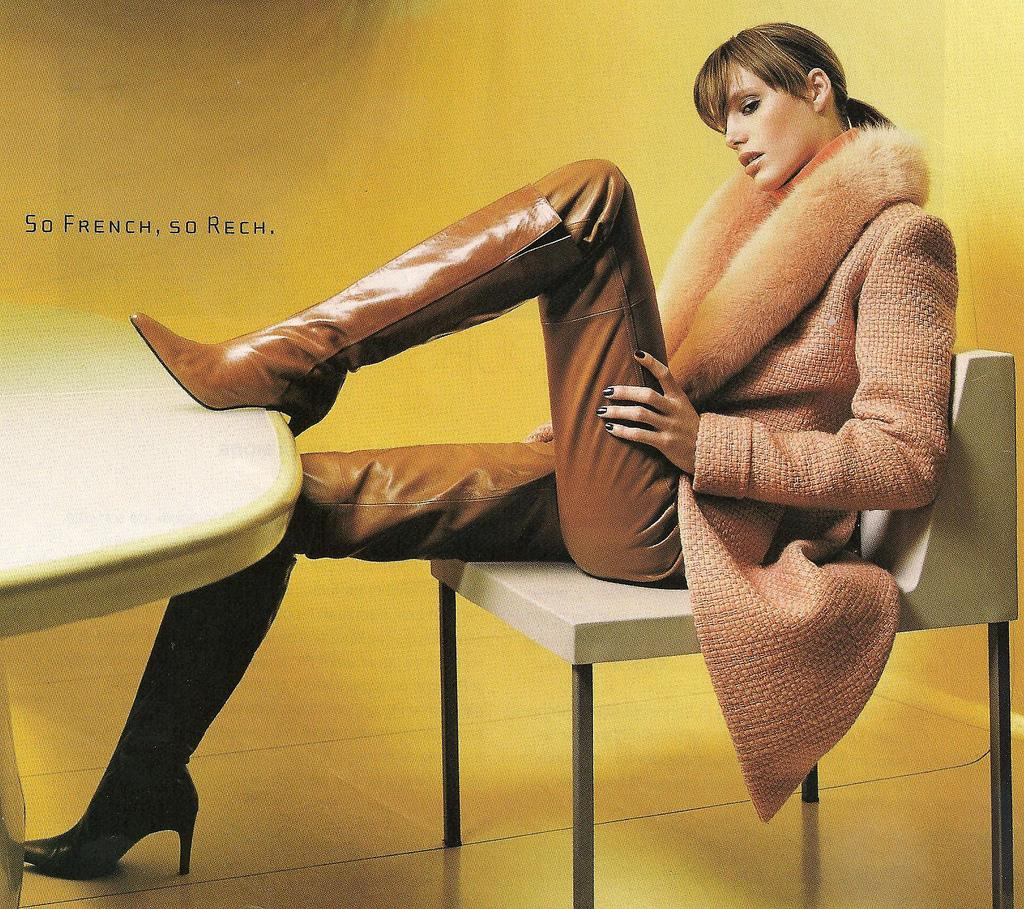What is the woman in the image doing? The woman is sitting on a chair in the image. What object is present in the image besides the woman? There is a table in the image. What color is the background in the image? The background appears to be yellow in color. What part of the room can be seen in the image? The floor is visible in the image. What type of drug is the woman taking in the image? There is no indication in the image that the woman is taking any drug, so it cannot be determined from the picture. 